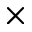<formula> <loc_0><loc_0><loc_500><loc_500>\times</formula> 